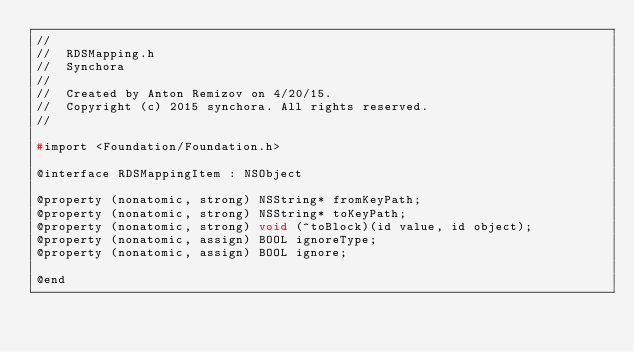Convert code to text. <code><loc_0><loc_0><loc_500><loc_500><_C_>//
//  RDSMapping.h
//  Synchora
//
//  Created by Anton Remizov on 4/20/15.
//  Copyright (c) 2015 synchora. All rights reserved.
//

#import <Foundation/Foundation.h>

@interface RDSMappingItem : NSObject

@property (nonatomic, strong) NSString* fromKeyPath;
@property (nonatomic, strong) NSString* toKeyPath;
@property (nonatomic, strong) void (^toBlock)(id value, id object);
@property (nonatomic, assign) BOOL ignoreType;
@property (nonatomic, assign) BOOL ignore;

@end
</code> 